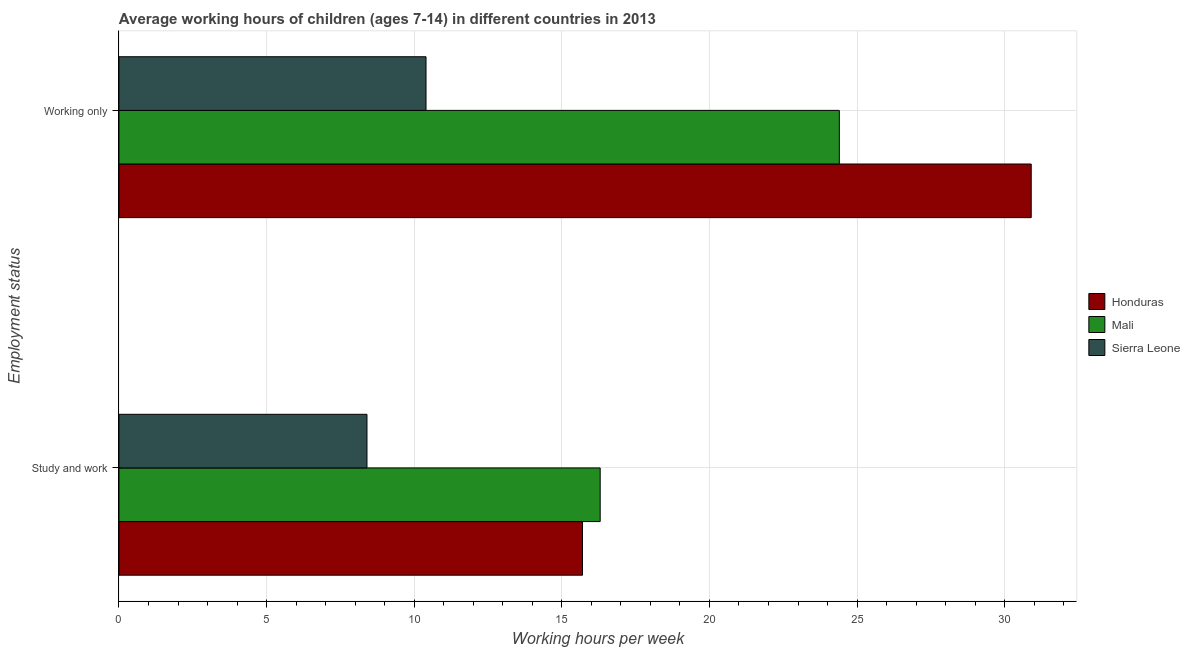How many different coloured bars are there?
Offer a very short reply. 3. Are the number of bars on each tick of the Y-axis equal?
Your response must be concise. Yes. What is the label of the 2nd group of bars from the top?
Provide a short and direct response. Study and work. What is the average working hour of children involved in study and work in Sierra Leone?
Give a very brief answer. 8.4. Across all countries, what is the minimum average working hour of children involved in study and work?
Offer a very short reply. 8.4. In which country was the average working hour of children involved in study and work maximum?
Your answer should be very brief. Mali. In which country was the average working hour of children involved in study and work minimum?
Provide a short and direct response. Sierra Leone. What is the total average working hour of children involved in only work in the graph?
Provide a succinct answer. 65.7. What is the difference between the average working hour of children involved in study and work in Honduras and that in Sierra Leone?
Offer a terse response. 7.3. What is the difference between the average working hour of children involved in study and work in Sierra Leone and the average working hour of children involved in only work in Honduras?
Provide a succinct answer. -22.5. What is the average average working hour of children involved in only work per country?
Provide a short and direct response. 21.9. In how many countries, is the average working hour of children involved in study and work greater than 7 hours?
Make the answer very short. 3. What is the ratio of the average working hour of children involved in study and work in Sierra Leone to that in Honduras?
Provide a succinct answer. 0.54. What does the 3rd bar from the top in Study and work represents?
Give a very brief answer. Honduras. What does the 3rd bar from the bottom in Working only represents?
Your answer should be very brief. Sierra Leone. Does the graph contain any zero values?
Provide a short and direct response. No. Where does the legend appear in the graph?
Provide a short and direct response. Center right. How many legend labels are there?
Offer a terse response. 3. How are the legend labels stacked?
Offer a terse response. Vertical. What is the title of the graph?
Your answer should be compact. Average working hours of children (ages 7-14) in different countries in 2013. Does "Trinidad and Tobago" appear as one of the legend labels in the graph?
Keep it short and to the point. No. What is the label or title of the X-axis?
Give a very brief answer. Working hours per week. What is the label or title of the Y-axis?
Your answer should be compact. Employment status. What is the Working hours per week of Honduras in Study and work?
Provide a short and direct response. 15.7. What is the Working hours per week in Mali in Study and work?
Your answer should be compact. 16.3. What is the Working hours per week of Sierra Leone in Study and work?
Give a very brief answer. 8.4. What is the Working hours per week in Honduras in Working only?
Ensure brevity in your answer.  30.9. What is the Working hours per week of Mali in Working only?
Ensure brevity in your answer.  24.4. Across all Employment status, what is the maximum Working hours per week in Honduras?
Provide a short and direct response. 30.9. Across all Employment status, what is the maximum Working hours per week in Mali?
Provide a short and direct response. 24.4. Across all Employment status, what is the maximum Working hours per week in Sierra Leone?
Offer a very short reply. 10.4. Across all Employment status, what is the minimum Working hours per week of Honduras?
Offer a terse response. 15.7. Across all Employment status, what is the minimum Working hours per week of Mali?
Provide a succinct answer. 16.3. What is the total Working hours per week of Honduras in the graph?
Ensure brevity in your answer.  46.6. What is the total Working hours per week of Mali in the graph?
Make the answer very short. 40.7. What is the difference between the Working hours per week of Honduras in Study and work and that in Working only?
Provide a succinct answer. -15.2. What is the difference between the Working hours per week in Honduras in Study and work and the Working hours per week in Mali in Working only?
Make the answer very short. -8.7. What is the difference between the Working hours per week in Honduras in Study and work and the Working hours per week in Sierra Leone in Working only?
Your answer should be very brief. 5.3. What is the difference between the Working hours per week of Mali in Study and work and the Working hours per week of Sierra Leone in Working only?
Give a very brief answer. 5.9. What is the average Working hours per week of Honduras per Employment status?
Provide a short and direct response. 23.3. What is the average Working hours per week in Mali per Employment status?
Give a very brief answer. 20.35. What is the average Working hours per week of Sierra Leone per Employment status?
Provide a short and direct response. 9.4. What is the difference between the Working hours per week of Honduras and Working hours per week of Mali in Study and work?
Provide a succinct answer. -0.6. What is the ratio of the Working hours per week of Honduras in Study and work to that in Working only?
Keep it short and to the point. 0.51. What is the ratio of the Working hours per week in Mali in Study and work to that in Working only?
Your response must be concise. 0.67. What is the ratio of the Working hours per week of Sierra Leone in Study and work to that in Working only?
Provide a succinct answer. 0.81. What is the difference between the highest and the second highest Working hours per week in Mali?
Provide a short and direct response. 8.1. What is the difference between the highest and the second highest Working hours per week of Sierra Leone?
Your answer should be compact. 2. What is the difference between the highest and the lowest Working hours per week of Sierra Leone?
Your response must be concise. 2. 